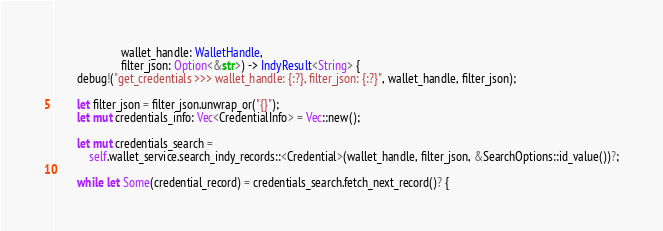Convert code to text. <code><loc_0><loc_0><loc_500><loc_500><_Rust_>                       wallet_handle: WalletHandle,
                       filter_json: Option<&str>) -> IndyResult<String> {
        debug!("get_credentials >>> wallet_handle: {:?}, filter_json: {:?}", wallet_handle, filter_json);

        let filter_json = filter_json.unwrap_or("{}");
        let mut credentials_info: Vec<CredentialInfo> = Vec::new();

        let mut credentials_search =
            self.wallet_service.search_indy_records::<Credential>(wallet_handle, filter_json, &SearchOptions::id_value())?;

        while let Some(credential_record) = credentials_search.fetch_next_record()? {</code> 